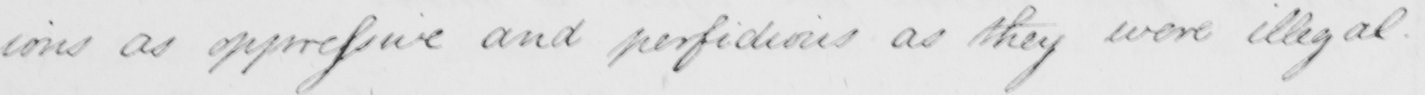What text is written in this handwritten line? ions as oppressive and perfidious as they were illegal . 